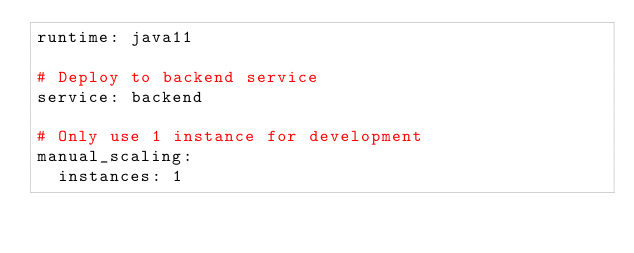Convert code to text. <code><loc_0><loc_0><loc_500><loc_500><_YAML_>runtime: java11

# Deploy to backend service
service: backend

# Only use 1 instance for development
manual_scaling:
  instances: 1</code> 